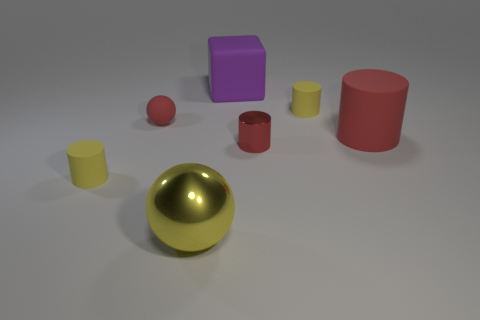Does the large cylinder have the same color as the small metallic thing that is in front of the block?
Keep it short and to the point. Yes. Does the ball on the left side of the big metal thing have the same color as the small metallic cylinder?
Keep it short and to the point. Yes. Do the matte sphere and the big cylinder have the same color?
Your answer should be compact. Yes. The red thing that is the same material as the large ball is what size?
Offer a terse response. Small. What number of red cylinders are the same size as the purple thing?
Your answer should be compact. 1. The metal object that is the same color as the rubber sphere is what size?
Give a very brief answer. Small. What size is the rubber object that is behind the tiny shiny object and in front of the matte sphere?
Provide a short and direct response. Large. How many matte cylinders are in front of the red metal cylinder that is to the right of the tiny cylinder on the left side of the purple thing?
Offer a very short reply. 1. Is there a tiny cylinder of the same color as the big shiny thing?
Keep it short and to the point. Yes. There is a rubber object that is the same size as the red matte cylinder; what color is it?
Your answer should be very brief. Purple. 